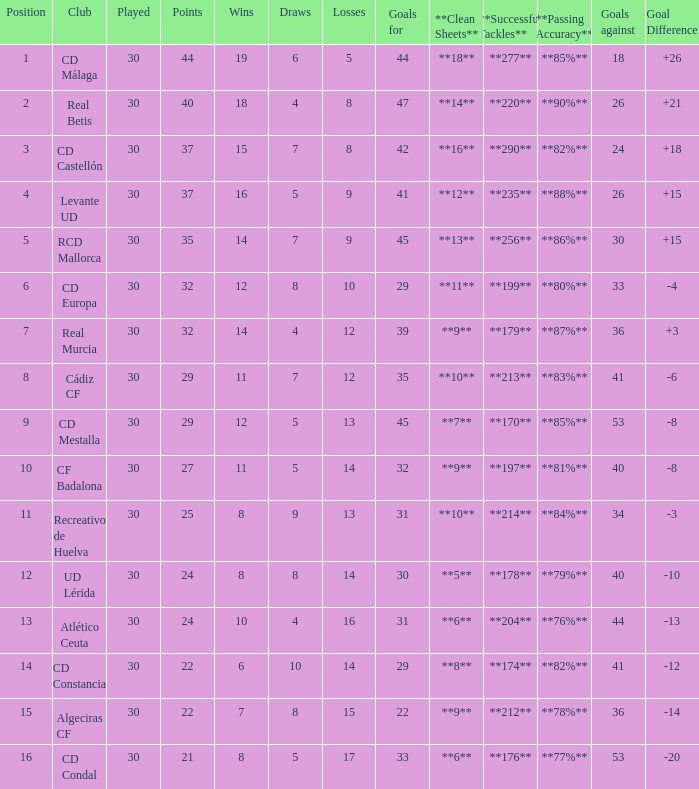What is the number of draws when played is smaller than 30? 0.0. 